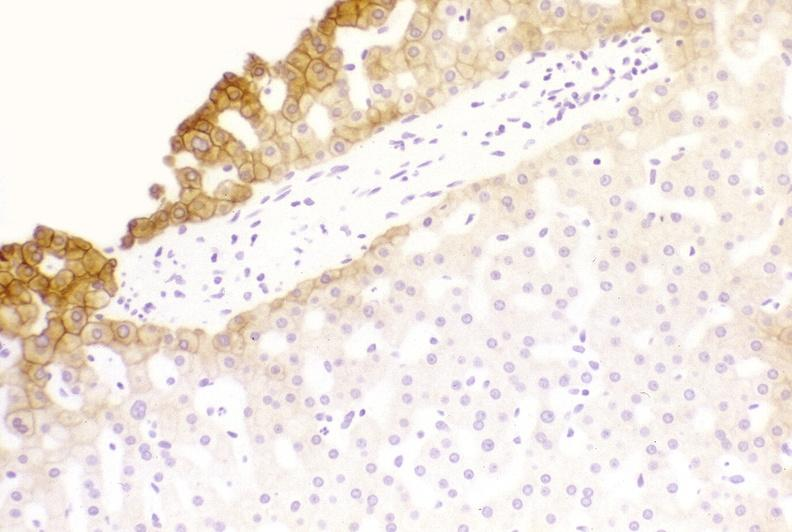what is present?
Answer the question using a single word or phrase. Liver 